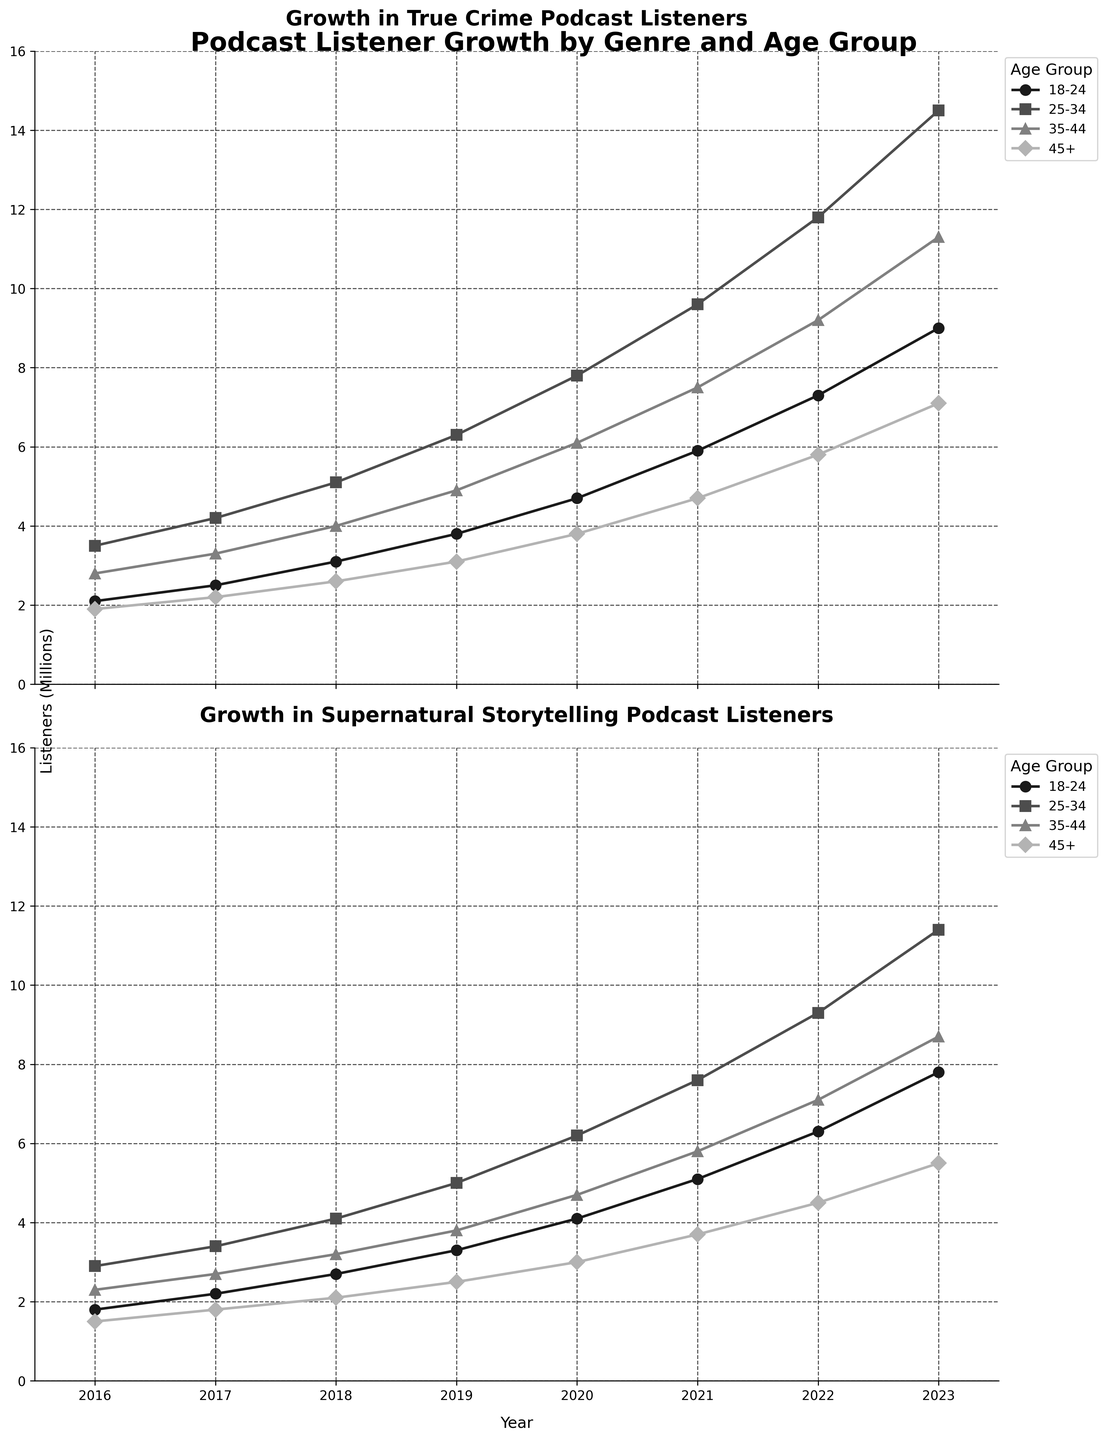what is the difference in the number of listeners for the 18-24 age group between 2023 and 2016 for True Crime? To find the difference in listeners, we subtract the number of listeners in 2016 from the number of listeners in 2023. In 2023, the number of listeners is 9.0 million, and in 2016, it is 2.1 million. Therefore, the difference is 9.0 - 2.1 = 6.9 million.
Answer: 6.9 million Which genre had a steeper growth in the 45+ age group between 2016 and 2023? To determine which genre had steeper growth, we compare the increase in listeners for the 45+ age group from 2016 to 2023 for both genres. For True Crime, the increase is from 1.9 million to 7.1 million, a growth of 5.2 million. For Supernatural, the increase is from 1.5 million to 5.5 million, a growth of 4.0 million. True Crime had a steeper growth in the 45+ age group.
Answer: True Crime How many more listeners did the 25-34 age group have for True Crime than Supernatural in 2023? We need to subtract the number of listeners for the 25-34 age group in the Supernatural genre from the number of listeners in the True Crime genre for the year 2023. For True Crime, it is 14.5 million, and for Supernatural, it is 11.4 million. Therefore, the difference is 14.5 - 11.4 = 3.1 million.
Answer: 3.1 million What is the average number of listeners in the 35-44 age group across all years for Supernatural? To find the average, we sum the number of listeners for the 35-44 age group for all years and divide by the number of years. The sum is 2.3 + 2.7 + 3.2 + 3.8 + 4.7 + 5.8 + 7.1 + 8.7 = 38.3 million. There are 8 years, so the average is 38.3 / 8 = 4.79 million.
Answer: 4.79 million Between the genres True Crime and Supernatural, which one had the highest growth in the 25-34 age group from 2018 to 2020? To find the highest growth, we calculate the increase in the number of listeners from 2018 to 2020 for both genres in the 25-34 age group. For True Crime, the increase is from 5.1 million to 7.8 million, a growth of 2.7 million. For Supernatural, the increase is from 4.1 million to 6.2 million, a growth of 2.1 million. True Crime had the highest growth.
Answer: True Crime Which age group had the highest number of listeners for Supernatural podcasts in 2023? We look at the 2023 data for Supernatural and find the number of listeners for each age group. 18-24 had 7.8 million, 25-34 had 11.4 million, 35-44 had 8.7 million, and 45+ had 5.5 million. The 25-34 age group had the highest number of listeners.
Answer: 25-34 Was there any age group for True Crime where the number of listeners decreased from one year to the next? To answer this, we check the listeners' numbers for each age group for every pair of consecutive years. For all age groups (18-24, 25-34, 35-44, 45+), the number of listeners consistently increased every year. No declines were noted.
Answer: No 